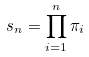Convert formula to latex. <formula><loc_0><loc_0><loc_500><loc_500>s _ { n } = \prod _ { i = 1 } ^ { n } \pi _ { i }</formula> 